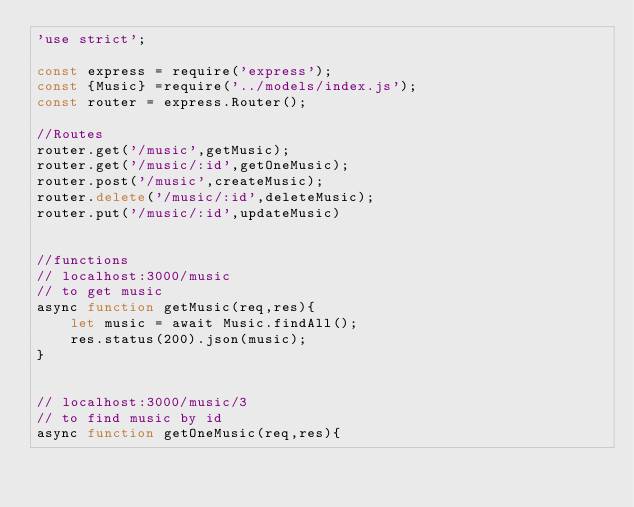Convert code to text. <code><loc_0><loc_0><loc_500><loc_500><_JavaScript_>'use strict';

const express = require('express');
const {Music} =require('../models/index.js');
const router = express.Router();

//Routes
router.get('/music',getMusic);
router.get('/music/:id',getOneMusic);
router.post('/music',createMusic);
router.delete('/music/:id',deleteMusic);
router.put('/music/:id',updateMusic)


//functions
// localhost:3000/music
// to get music 
async function getMusic(req,res){
    let music = await Music.findAll();
    res.status(200).json(music);
}


// localhost:3000/music/3
// to find music by id 
async function getOneMusic(req,res){</code> 